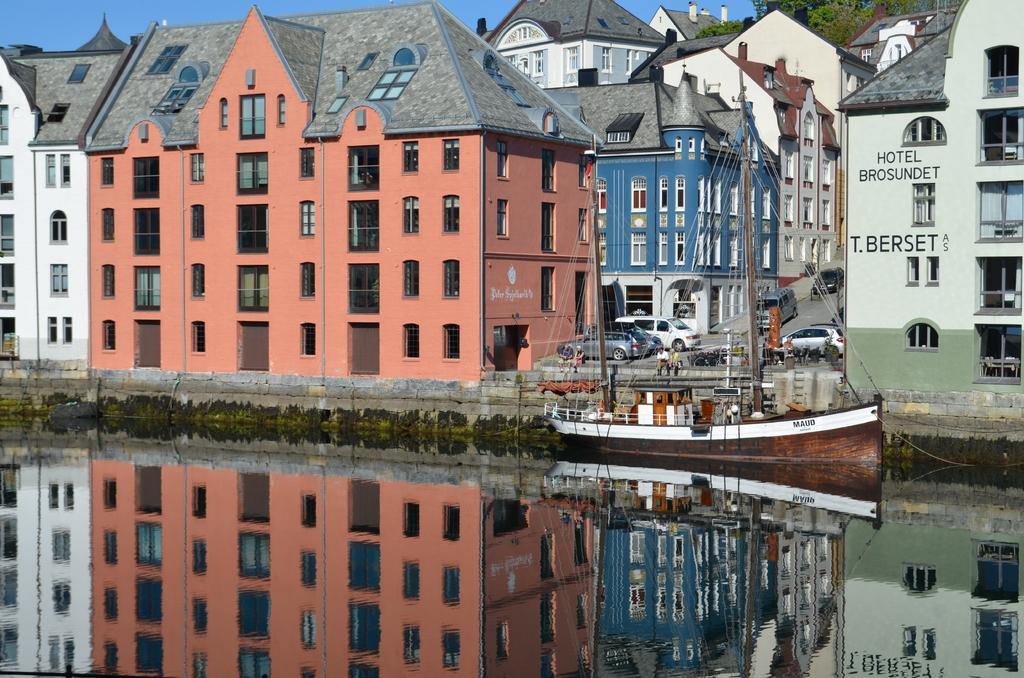What type of structures are present in the image? There are buildings with windows in the image. What is the large object floating in the water? There is a ship in the image. What type of vegetation can be seen in the image? There are plants in the image. What natural element is visible in the image? Water is visible in the image. What is visible above the buildings and the ship? The sky is visible in the image. Can you see any arms holding balls in the image? There are no arms or balls present in the image. What type of screw is being used to hold the ship together in the image? There is no screw visible in the image; it is a ship floating in the water. 